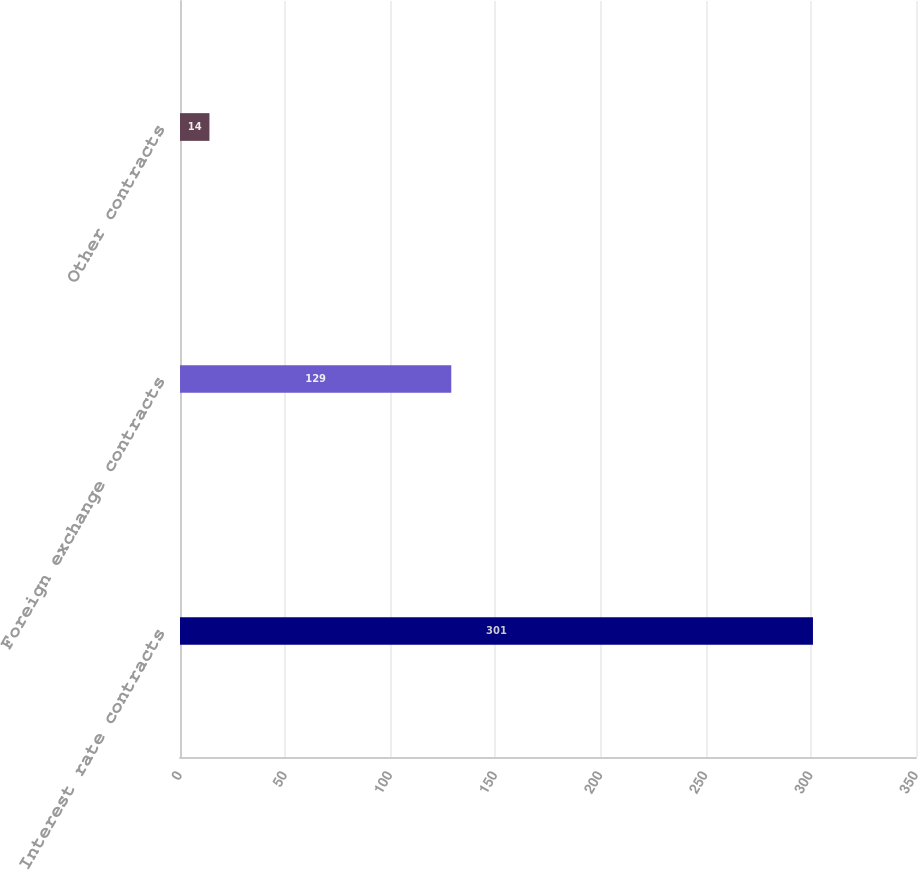Convert chart to OTSL. <chart><loc_0><loc_0><loc_500><loc_500><bar_chart><fcel>Interest rate contracts<fcel>Foreign exchange contracts<fcel>Other contracts<nl><fcel>301<fcel>129<fcel>14<nl></chart> 